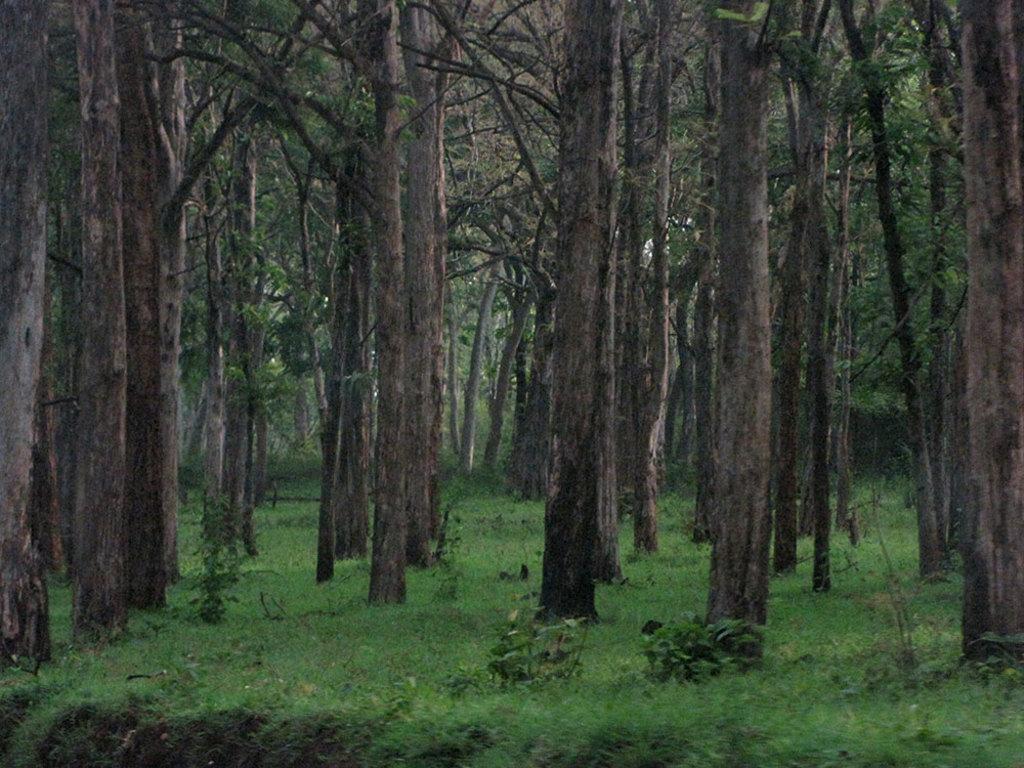How would you summarize this image in a sentence or two? In this image we can see trees, plants and grass on the ground. 